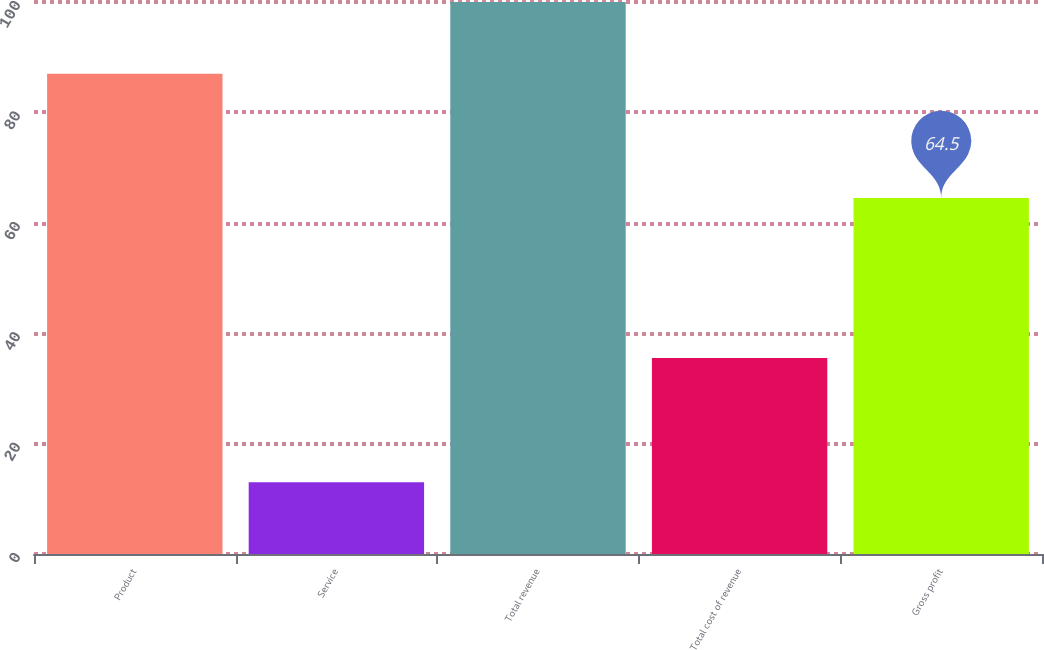Convert chart to OTSL. <chart><loc_0><loc_0><loc_500><loc_500><bar_chart><fcel>Product<fcel>Service<fcel>Total revenue<fcel>Total cost of revenue<fcel>Gross profit<nl><fcel>87<fcel>13<fcel>100<fcel>35.5<fcel>64.5<nl></chart> 